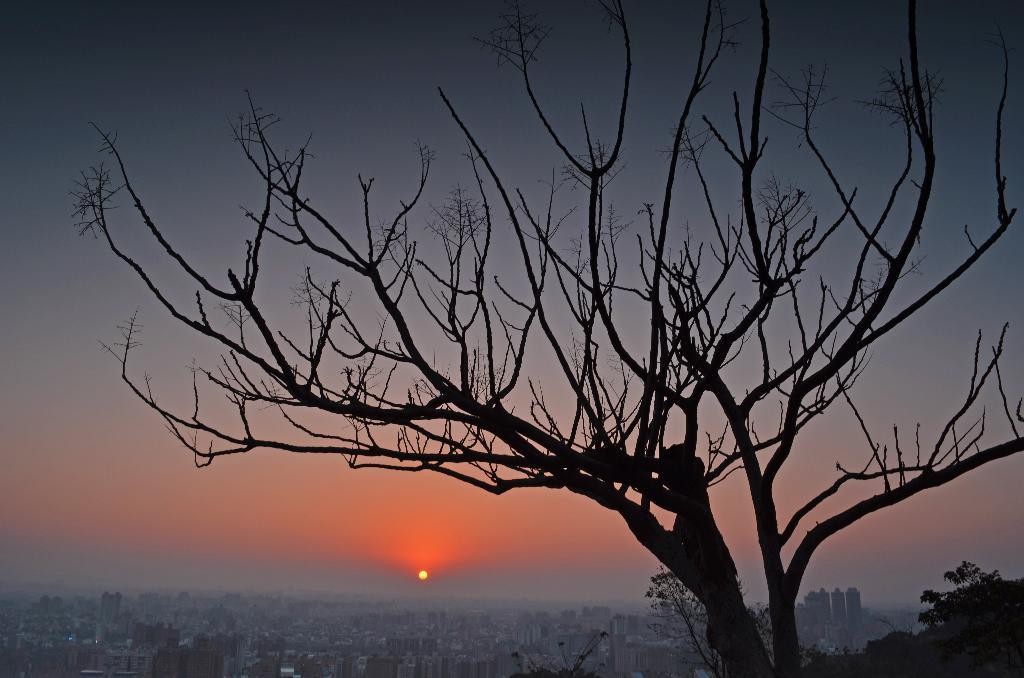What time of day is depicted in the image? The image depicts a sunset. What structures can be seen in the image? There are buildings in the image. What type of natural vegetation is present in the image? Trees are present in the image. What is visible in the background of the image? The sky is visible in the image. What plot of land is the church located on in the image? There is no church present in the image, so it is not possible to determine the plot of land it might be located on. 